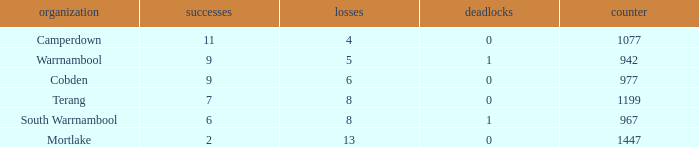How many wins did Cobden have when draws were more than 0? 0.0. 